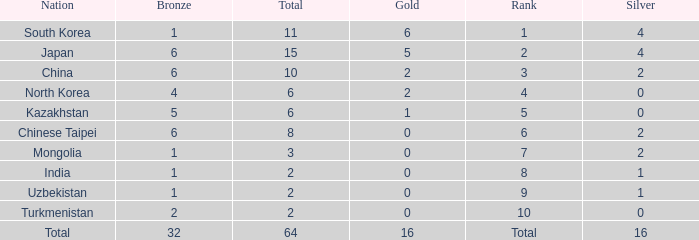What rank is Turkmenistan, who had 0 silver's and Less than 2 golds? 10.0. 